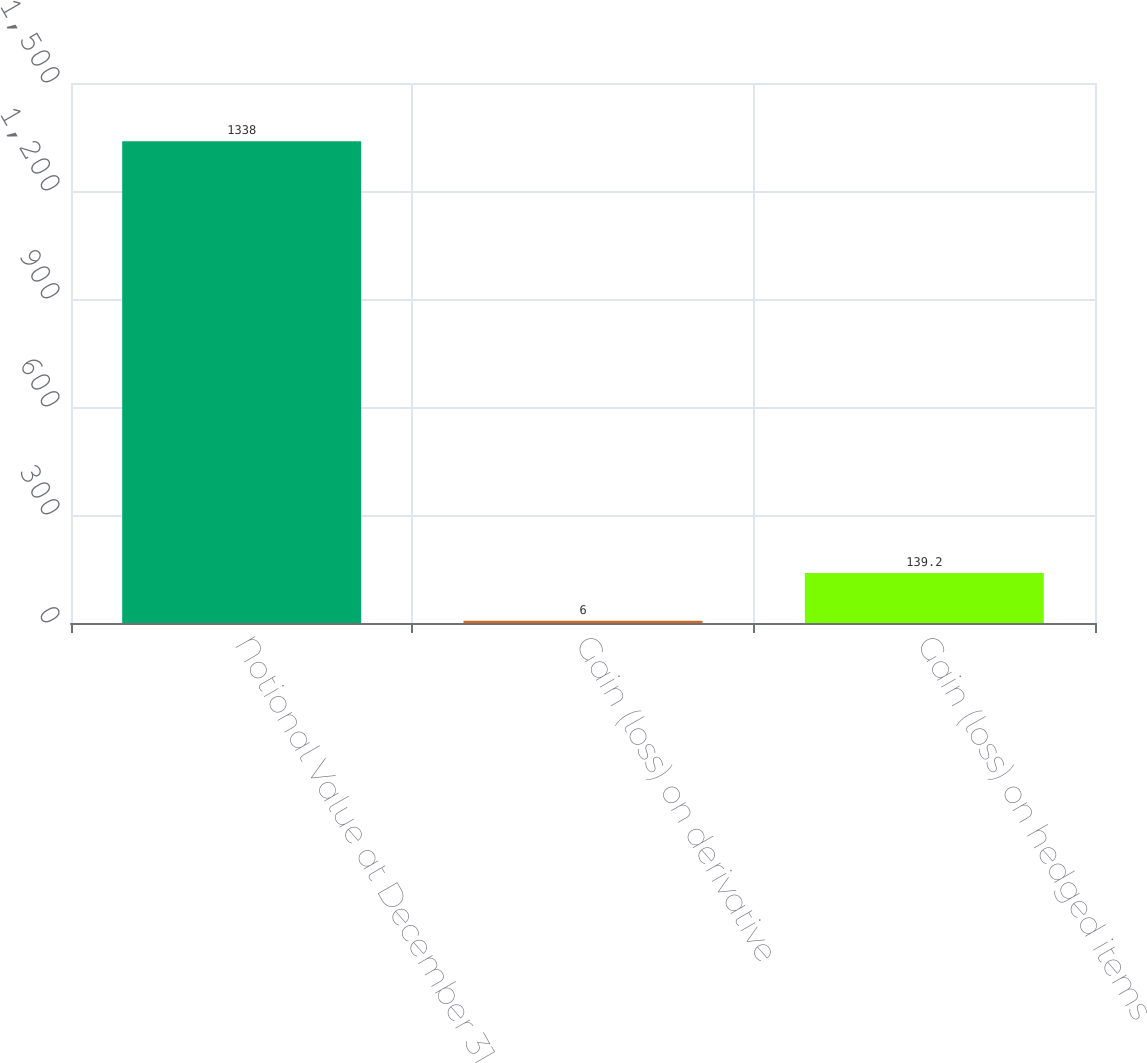<chart> <loc_0><loc_0><loc_500><loc_500><bar_chart><fcel>Notional Value at December 31<fcel>Gain (loss) on derivative<fcel>Gain (loss) on hedged items<nl><fcel>1338<fcel>6<fcel>139.2<nl></chart> 